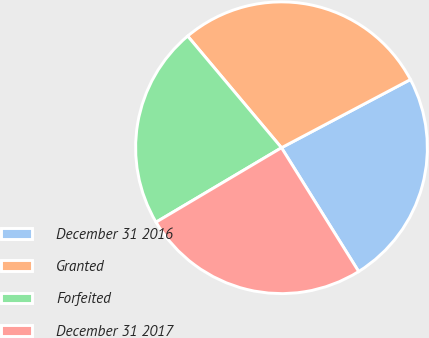Convert chart. <chart><loc_0><loc_0><loc_500><loc_500><pie_chart><fcel>December 31 2016<fcel>Granted<fcel>Forfeited<fcel>December 31 2017<nl><fcel>23.87%<fcel>28.38%<fcel>22.4%<fcel>25.35%<nl></chart> 